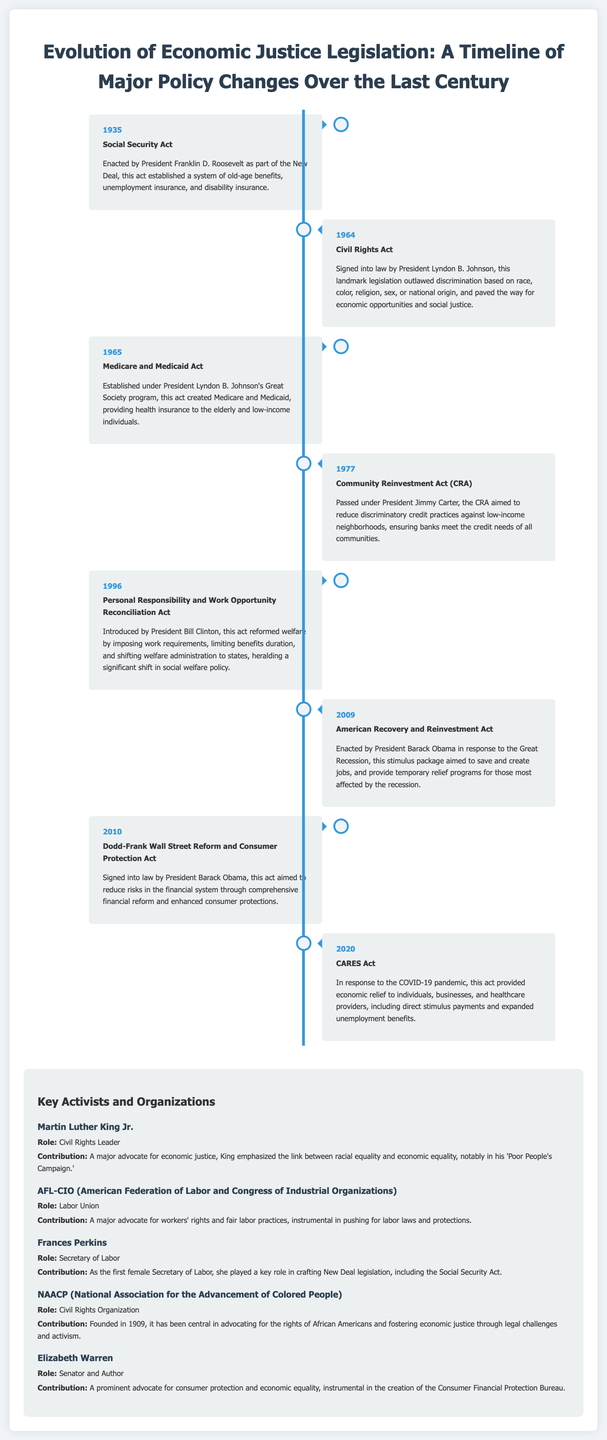What year was the Social Security Act enacted? The Social Security Act is noted in the timeline as having been enacted in 1935.
Answer: 1935 Who signed the Civil Rights Act into law? The timeline states that the Civil Rights Act was signed into law by President Lyndon B. Johnson.
Answer: Lyndon B. Johnson What legislation introduced work requirements for welfare? The timeline lists the Personal Responsibility and Work Opportunity Reconciliation Act as the legislation that introduced work requirements for welfare in 1996.
Answer: Personal Responsibility and Work Opportunity Reconciliation Act What did the Community Reinvestment Act aim to reduce? The document indicates that the Community Reinvestment Act aimed to reduce discriminatory credit practices against low-income neighborhoods.
Answer: Discriminatory credit practices Which prominent activist emphasized the link between racial equality and economic equality? The timeline describes Martin Luther King Jr. as an activist who emphasized the link between racial equality and economic equality.
Answer: Martin Luther King Jr What act was created in response to the Great Recession? The timeline notes that the American Recovery and Reinvestment Act was enacted in response to the Great Recession in 2009.
Answer: American Recovery and Reinvestment Act Which organization was central in advocating for African American rights? The NAACP is named in the timeline as a civil rights organization central to advocating for the rights of African Americans.
Answer: NAACP What year did Medicare and Medicaid get established? According to the timeline, Medicare and Medicaid were established in 1965.
Answer: 1965 What role did Frances Perkins have in the U.S. government? The timeline indicates that Frances Perkins was the Secretary of Labor.
Answer: Secretary of Labor 